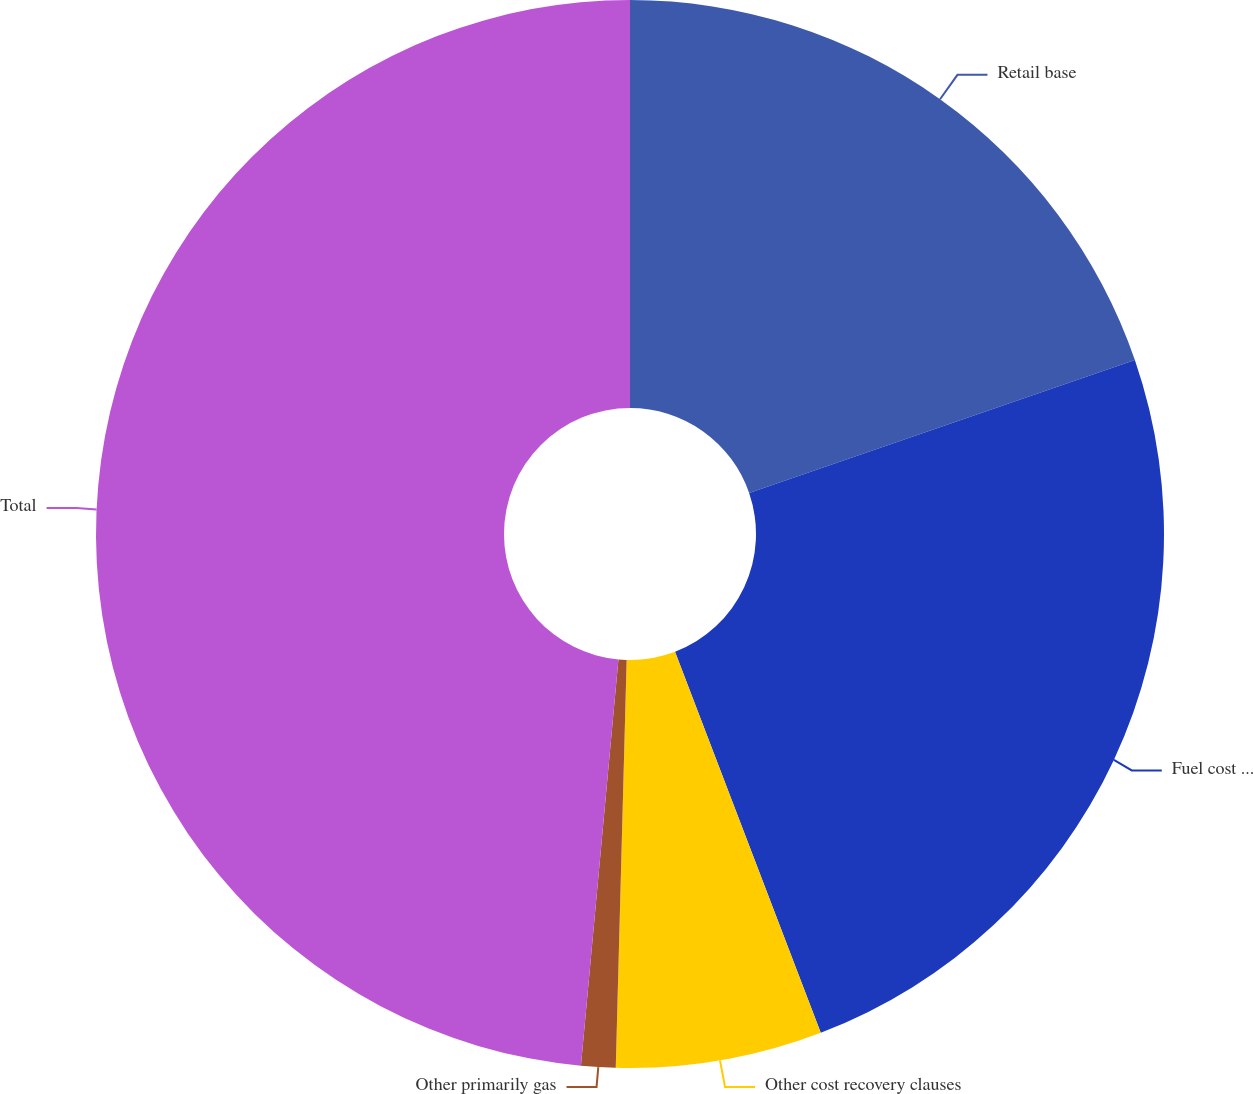<chart> <loc_0><loc_0><loc_500><loc_500><pie_chart><fcel>Retail base<fcel>Fuel cost recovery<fcel>Other cost recovery clauses<fcel>Other primarily gas<fcel>Total<nl><fcel>19.72%<fcel>24.47%<fcel>6.24%<fcel>1.04%<fcel>48.54%<nl></chart> 